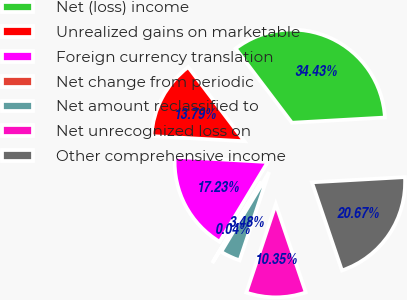Convert chart. <chart><loc_0><loc_0><loc_500><loc_500><pie_chart><fcel>Net (loss) income<fcel>Unrealized gains on marketable<fcel>Foreign currency translation<fcel>Net change from periodic<fcel>Net amount reclassified to<fcel>Net unrecognized loss on<fcel>Other comprehensive income<nl><fcel>34.43%<fcel>13.79%<fcel>17.23%<fcel>0.04%<fcel>3.48%<fcel>10.35%<fcel>20.67%<nl></chart> 